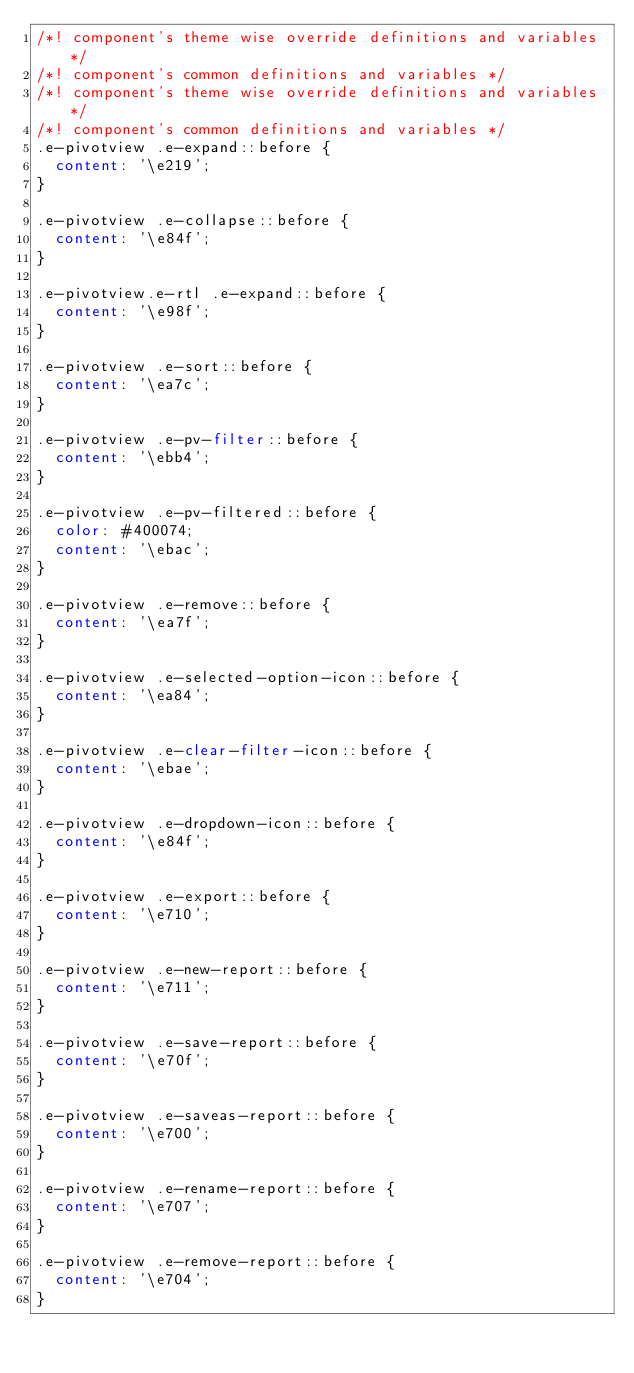Convert code to text. <code><loc_0><loc_0><loc_500><loc_500><_CSS_>/*! component's theme wise override definitions and variables */
/*! component's common definitions and variables */
/*! component's theme wise override definitions and variables */
/*! component's common definitions and variables */
.e-pivotview .e-expand::before {
  content: '\e219';
}

.e-pivotview .e-collapse::before {
  content: '\e84f';
}

.e-pivotview.e-rtl .e-expand::before {
  content: '\e98f';
}

.e-pivotview .e-sort::before {
  content: '\ea7c';
}

.e-pivotview .e-pv-filter::before {
  content: '\ebb4';
}

.e-pivotview .e-pv-filtered::before {
  color: #400074;
  content: '\ebac';
}

.e-pivotview .e-remove::before {
  content: '\ea7f';
}

.e-pivotview .e-selected-option-icon::before {
  content: '\ea84';
}

.e-pivotview .e-clear-filter-icon::before {
  content: '\ebae';
}

.e-pivotview .e-dropdown-icon::before {
  content: '\e84f';
}

.e-pivotview .e-export::before {
  content: '\e710';
}

.e-pivotview .e-new-report::before {
  content: '\e711';
}

.e-pivotview .e-save-report::before {
  content: '\e70f';
}

.e-pivotview .e-saveas-report::before {
  content: '\e700';
}

.e-pivotview .e-rename-report::before {
  content: '\e707';
}

.e-pivotview .e-remove-report::before {
  content: '\e704';
}
</code> 